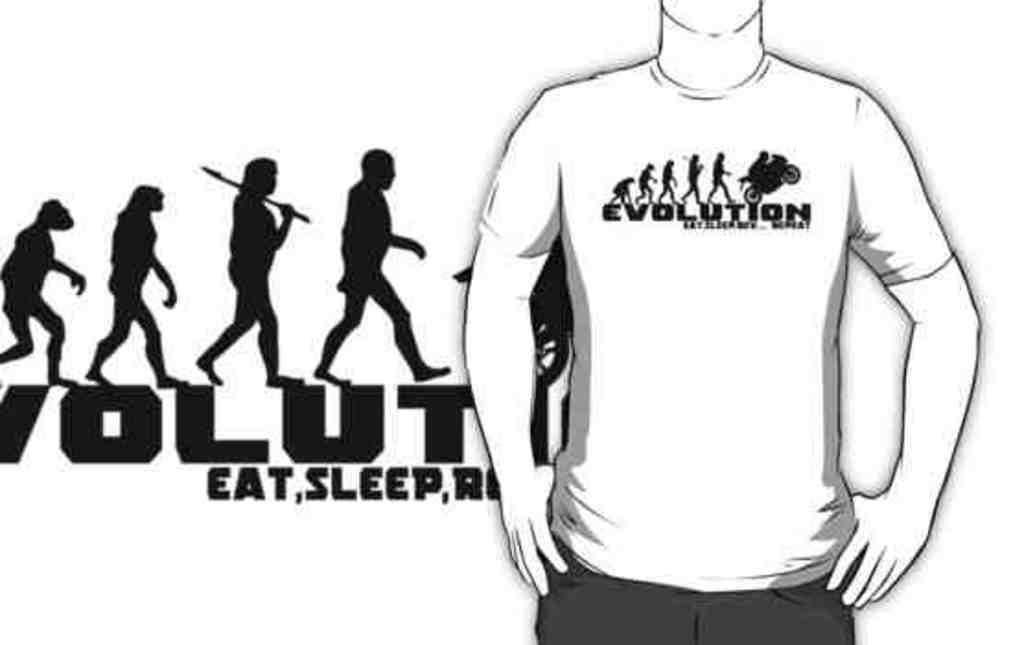What type of drawing is featured in the image? The image contains a sketch of a person without a head and a sketch of an ape man. What else can be found on the image besides the drawings? There is some text on the image. What type of mitten is the dad wearing in the image? There is no dad or mitten present in the image; it only contains sketches of a person without a head and an ape man, along with some text. 